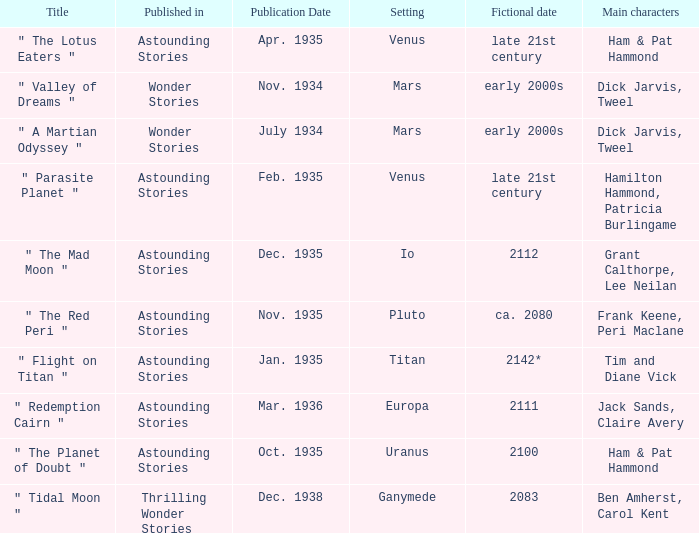Name the publication date when the fictional date is 2112 Dec. 1935. 